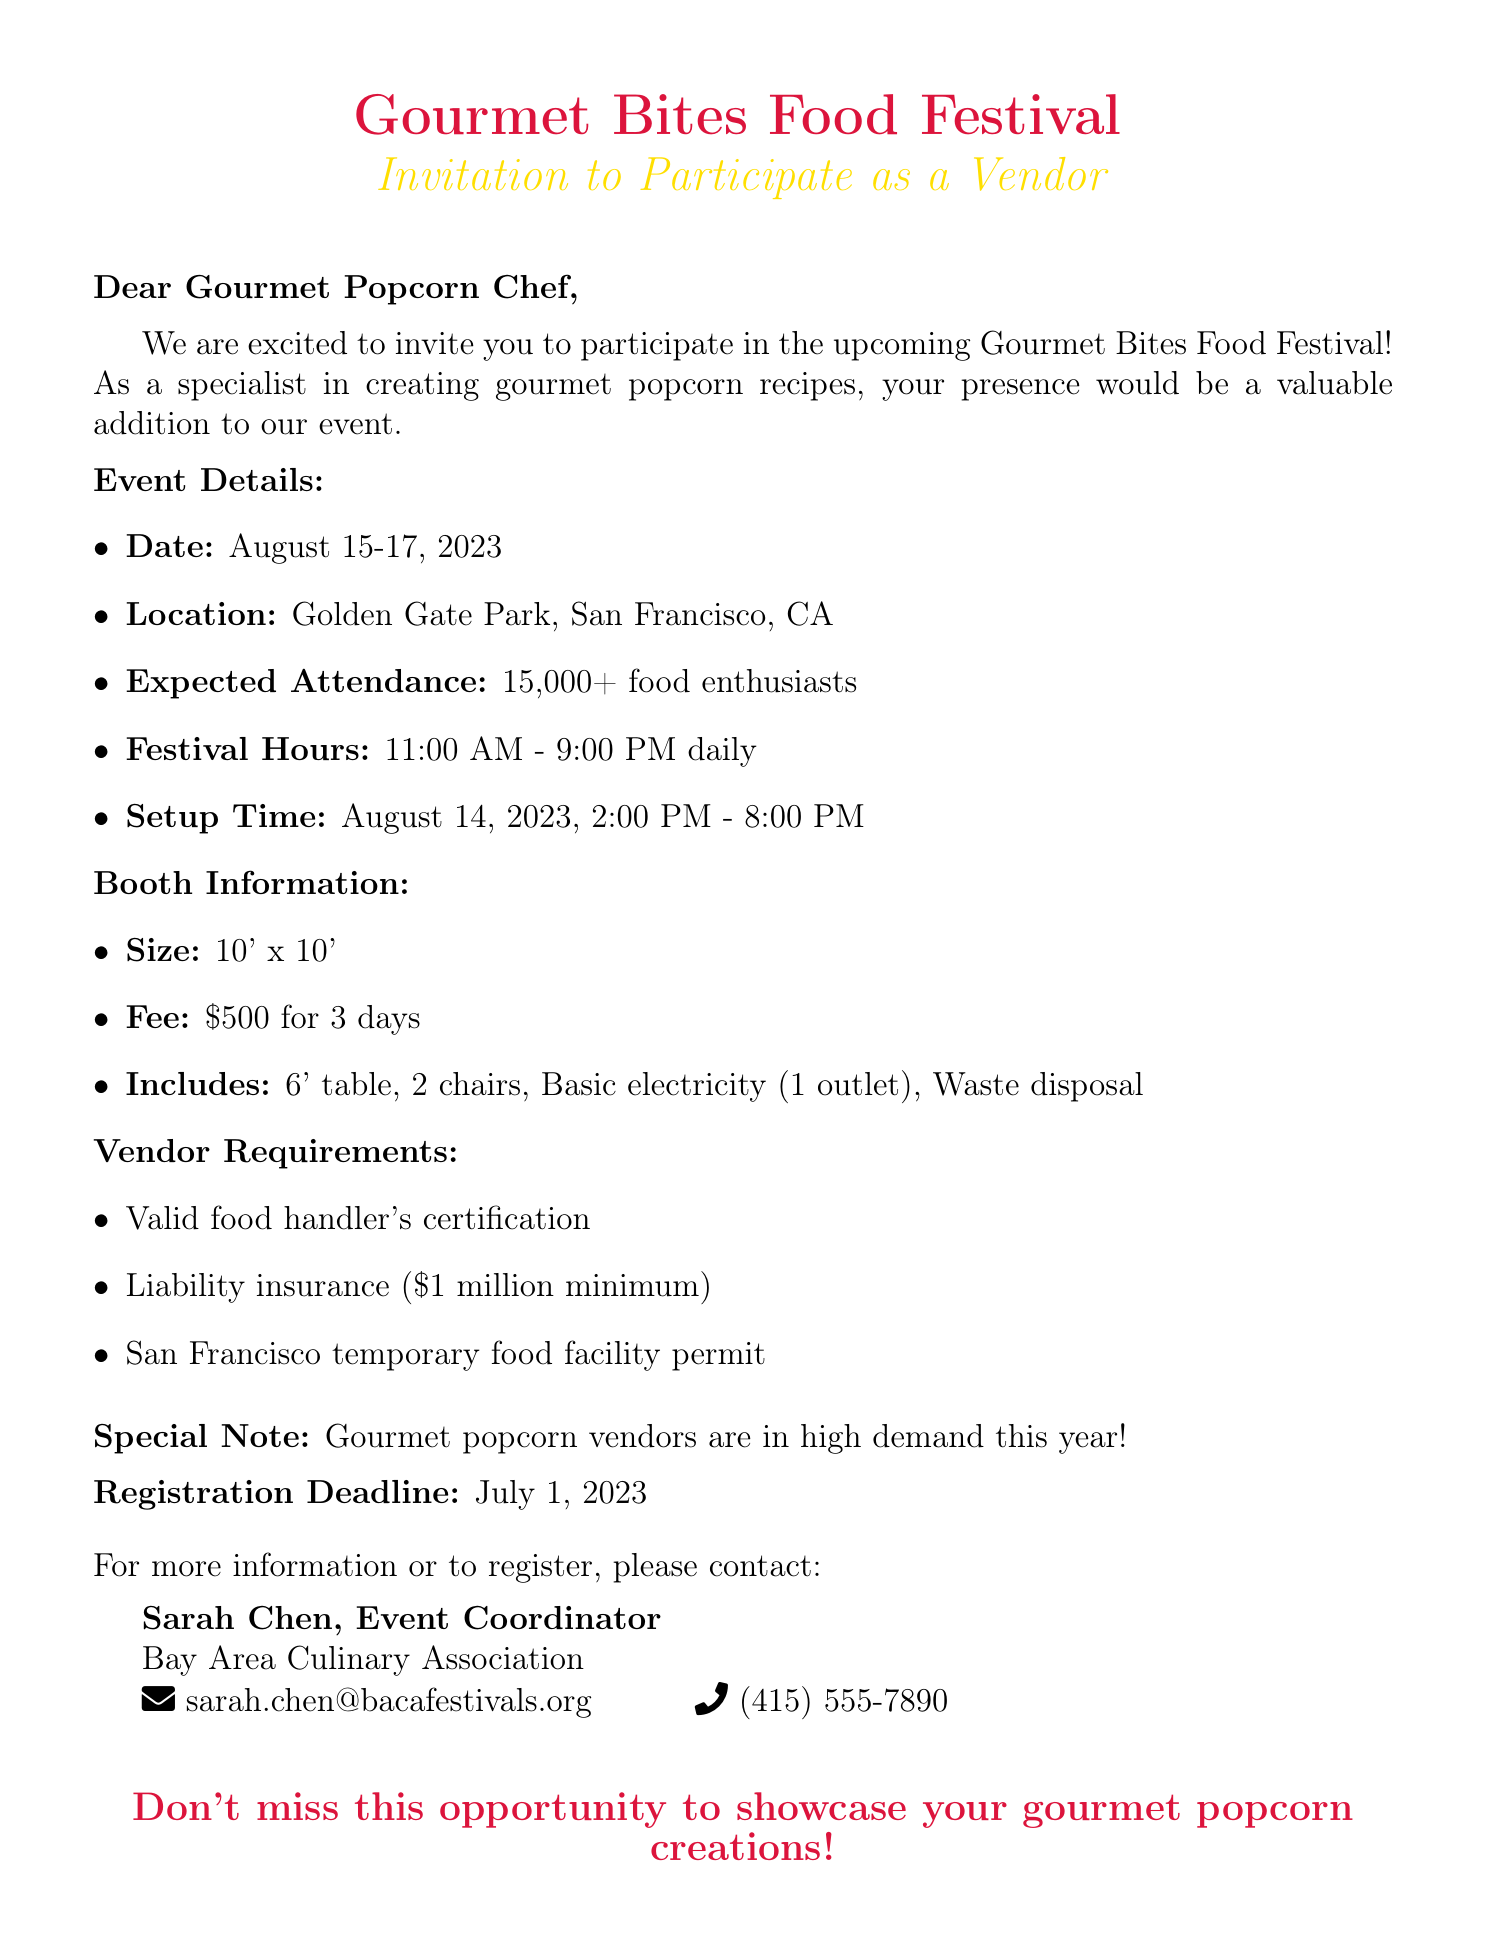what are the festival dates? The festival dates are specified in the event details section of the document.
Answer: August 15-17, 2023 where is the event located? The location of the event is mentioned in the event details section.
Answer: Golden Gate Park, San Francisco, CA what is the booth fee? The booth fee is listed in the booth information section of the document.
Answer: $500 for 3 days how large is each vendor booth? The size of the vendor booth is provided in the booth information section.
Answer: 10' x 10' what is the registration deadline? The registration deadline is clearly mentioned in the document.
Answer: July 1, 2023 what type of permit is required? The required permit for vendors is noted in the vendor requirements section.
Answer: San Francisco temporary food facility permit who is the event coordinator? The event coordinator's name is provided in the contact information section.
Answer: Sarah Chen how many expected attendees are there? The expected attendance figure is included in the event details section.
Answer: 15,000+ what is the setup time for vendors? The setup time is specified in the event details section of the document.
Answer: August 14, 2023, 2:00 PM - 8:00 PM what minimum liability insurance is needed? The minimum liability insurance amount is indicated in the vendor requirements.
Answer: $1 million minimum 